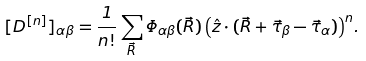Convert formula to latex. <formula><loc_0><loc_0><loc_500><loc_500>[ { D } ^ { [ n ] } ] _ { \alpha \beta } = \frac { 1 } { n ! } \sum _ { \vec { R } } { \Phi _ { \alpha \beta } ( \vec { R } ) \left ( { \hat { z } } \cdot ( \vec { R } + \vec { \tau } _ { \beta } - \vec { \tau } _ { \alpha } ) \right ) ^ { n } } .</formula> 